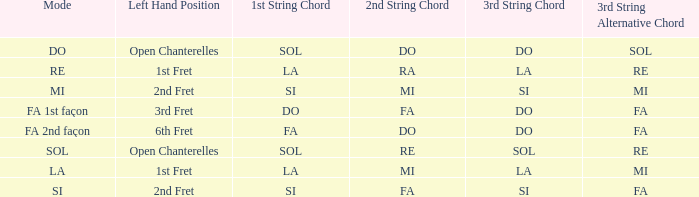What is the Depart de la main gauche of the do Mode? Chanterelles jouant à vide. 